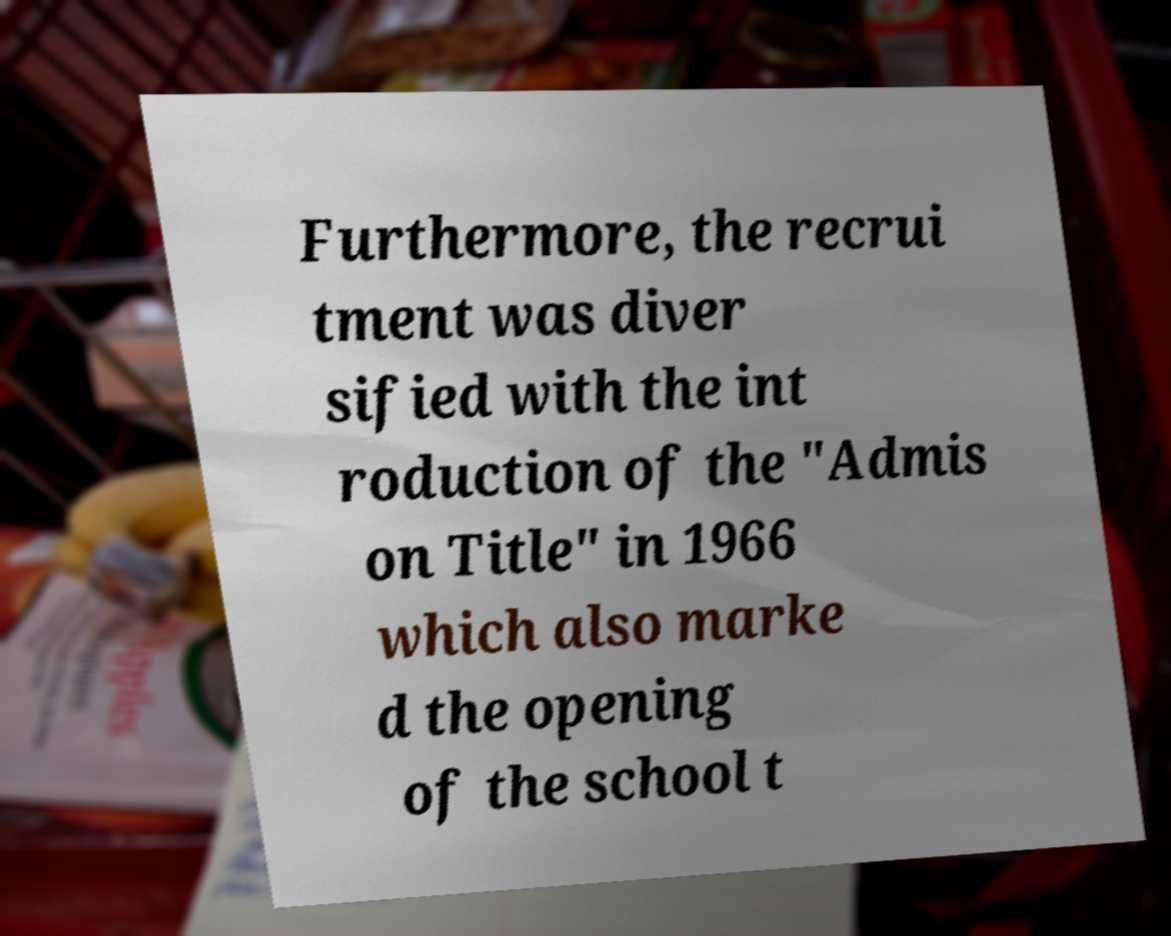Could you extract and type out the text from this image? Furthermore, the recrui tment was diver sified with the int roduction of the "Admis on Title" in 1966 which also marke d the opening of the school t 